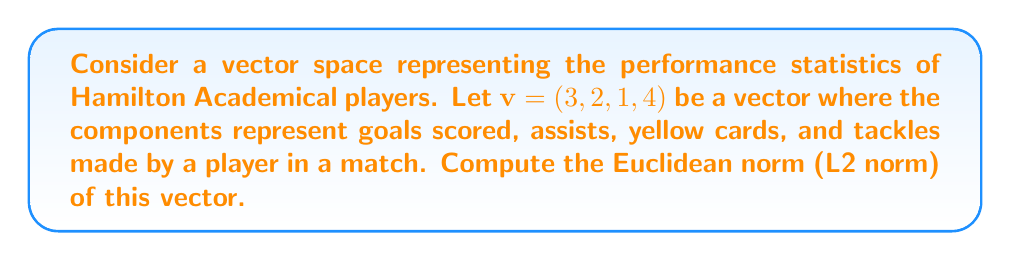Could you help me with this problem? To compute the Euclidean norm (L2 norm) of a vector, we use the formula:

$$\|v\|_2 = \sqrt{\sum_{i=1}^n |v_i|^2}$$

Where $v_i$ are the components of the vector and $n$ is the dimension of the vector.

For our vector $v = (3, 2, 1, 4)$, we have:

1. Square each component:
   $3^2 = 9$
   $2^2 = 4$
   $1^2 = 1$
   $4^2 = 16$

2. Sum the squared values:
   $9 + 4 + 1 + 16 = 30$

3. Take the square root of the sum:
   $\sqrt{30}$

Therefore, the Euclidean norm of the vector is $\sqrt{30}$.
Answer: $\|v\|_2 = \sqrt{30}$ 